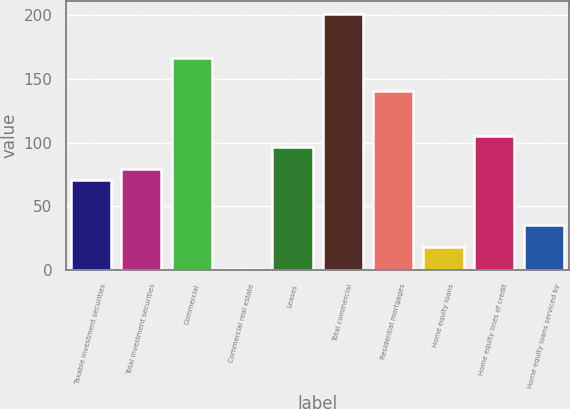Convert chart. <chart><loc_0><loc_0><loc_500><loc_500><bar_chart><fcel>Taxable investment securities<fcel>Total investment securities<fcel>Commercial<fcel>Commercial real estate<fcel>Leases<fcel>Total commercial<fcel>Residential mortgages<fcel>Home equity loans<fcel>Home equity lines of credit<fcel>Home equity loans serviced by<nl><fcel>70.6<fcel>79.3<fcel>166.3<fcel>1<fcel>96.7<fcel>201.1<fcel>140.2<fcel>18.4<fcel>105.4<fcel>35.8<nl></chart> 